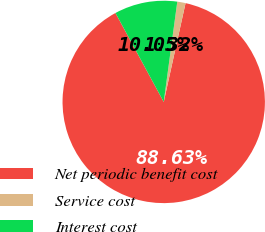Convert chart. <chart><loc_0><loc_0><loc_500><loc_500><pie_chart><fcel>Net periodic benefit cost<fcel>Service cost<fcel>Interest cost<nl><fcel>88.62%<fcel>1.32%<fcel>10.05%<nl></chart> 